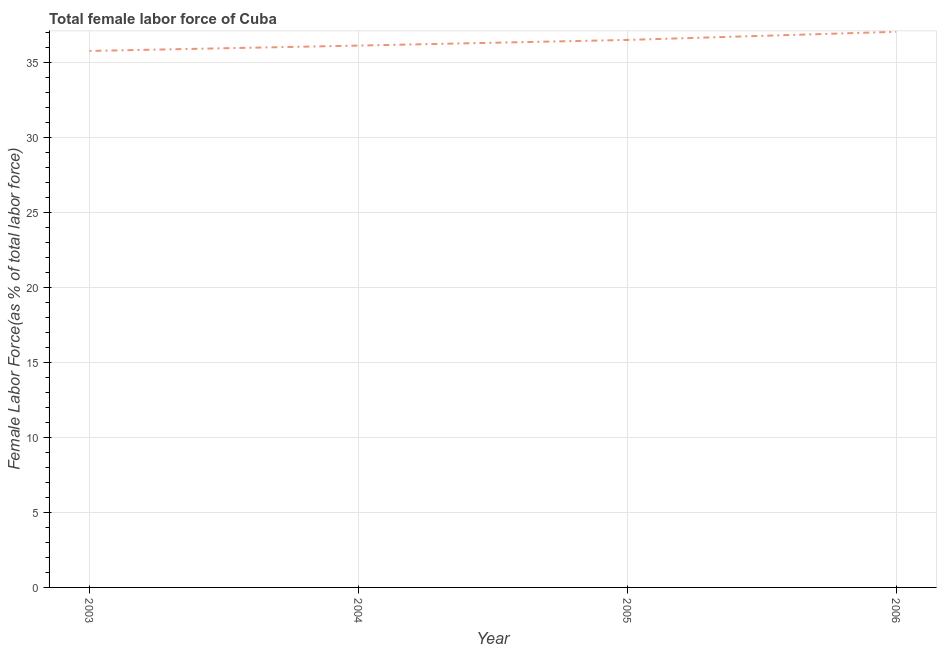What is the total female labor force in 2005?
Offer a terse response. 36.53. Across all years, what is the maximum total female labor force?
Make the answer very short. 37.07. Across all years, what is the minimum total female labor force?
Provide a succinct answer. 35.79. What is the sum of the total female labor force?
Provide a short and direct response. 145.54. What is the difference between the total female labor force in 2004 and 2005?
Provide a short and direct response. -0.38. What is the average total female labor force per year?
Your answer should be very brief. 36.39. What is the median total female labor force?
Your response must be concise. 36.34. In how many years, is the total female labor force greater than 7 %?
Give a very brief answer. 4. Do a majority of the years between 2003 and 2005 (inclusive) have total female labor force greater than 35 %?
Ensure brevity in your answer.  Yes. What is the ratio of the total female labor force in 2003 to that in 2005?
Your response must be concise. 0.98. Is the difference between the total female labor force in 2004 and 2005 greater than the difference between any two years?
Your response must be concise. No. What is the difference between the highest and the second highest total female labor force?
Make the answer very short. 0.54. Is the sum of the total female labor force in 2003 and 2006 greater than the maximum total female labor force across all years?
Make the answer very short. Yes. What is the difference between the highest and the lowest total female labor force?
Offer a very short reply. 1.28. Does the total female labor force monotonically increase over the years?
Provide a succinct answer. Yes. How many lines are there?
Ensure brevity in your answer.  1. Does the graph contain grids?
Offer a terse response. Yes. What is the title of the graph?
Provide a succinct answer. Total female labor force of Cuba. What is the label or title of the Y-axis?
Make the answer very short. Female Labor Force(as % of total labor force). What is the Female Labor Force(as % of total labor force) of 2003?
Keep it short and to the point. 35.79. What is the Female Labor Force(as % of total labor force) in 2004?
Your answer should be very brief. 36.15. What is the Female Labor Force(as % of total labor force) of 2005?
Make the answer very short. 36.53. What is the Female Labor Force(as % of total labor force) of 2006?
Offer a terse response. 37.07. What is the difference between the Female Labor Force(as % of total labor force) in 2003 and 2004?
Give a very brief answer. -0.36. What is the difference between the Female Labor Force(as % of total labor force) in 2003 and 2005?
Your answer should be compact. -0.73. What is the difference between the Female Labor Force(as % of total labor force) in 2003 and 2006?
Make the answer very short. -1.28. What is the difference between the Female Labor Force(as % of total labor force) in 2004 and 2005?
Offer a very short reply. -0.38. What is the difference between the Female Labor Force(as % of total labor force) in 2004 and 2006?
Offer a very short reply. -0.92. What is the difference between the Female Labor Force(as % of total labor force) in 2005 and 2006?
Your answer should be compact. -0.54. What is the ratio of the Female Labor Force(as % of total labor force) in 2003 to that in 2005?
Your response must be concise. 0.98. What is the ratio of the Female Labor Force(as % of total labor force) in 2004 to that in 2005?
Keep it short and to the point. 0.99. 